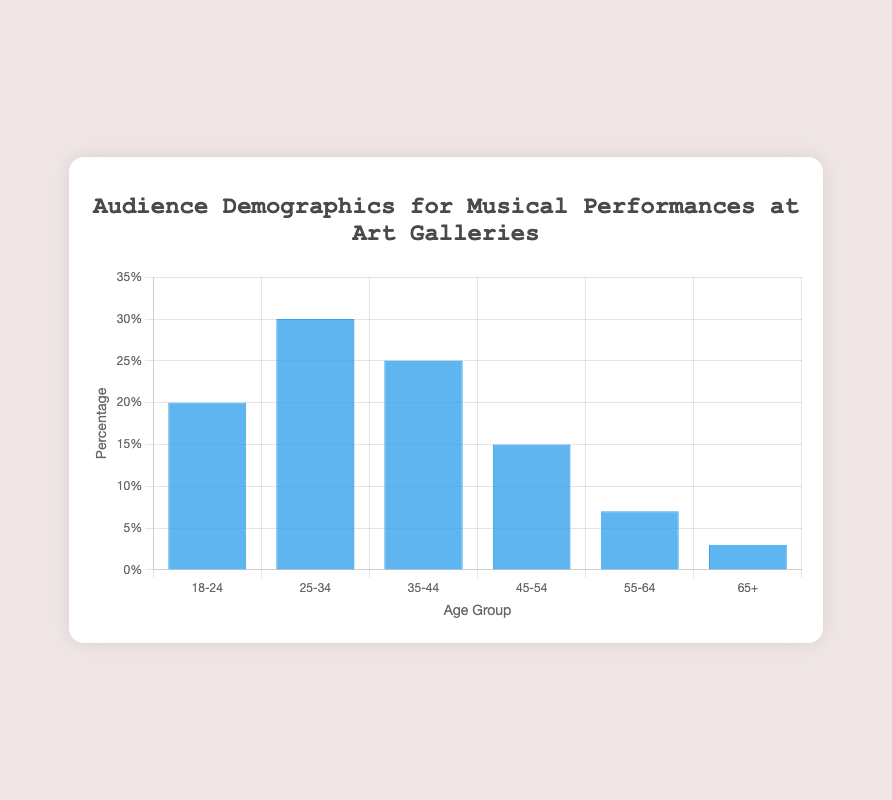Which age group has the highest percentage of the audience? The bar representing the 25-34 age group is the tallest among all the bars. Therefore, the 25-34 age group has the highest percentage.
Answer: 25-34 What is the total percentage of audiences aged 35-54? Sum the percentages of the 35-44 and 45-54 age groups: 25% + 15% = 40%.
Answer: 40% Which age group has a lower percentage of the audience, 55-64 or 65+? Compare the heights of the bars for the 55-64 and 65+ age groups. The 65+ age group has a shorter bar.
Answer: 65+ How much greater is the percentage of the 18-24 age group compared to the 65+ age group? Subtract the percentage of the 65+ age group from the percentage of the 18-24 age group: 20% - 3% = 17%.
Answer: 17% If you combine the percentages of the 18-24 and 25-34 age groups, what is the sum? Add the percentages of the 18-24 and 25-34 age groups: 20% + 30% = 50%.
Answer: 50% Which age group has more than double the percentage of the 55-64 age group? Double the percentage of the 55-64 age group (7% * 2 = 14%). The age groups with percentages greater than 14% are 18-24, 25-34, 35-44, and 45-54. Among these, 18-24, 25-34, and 35-44 age groups have more than double the percentage.
Answer: 18-24, 25-34, 35-44 What is the average percentage of the 35-44 and 45-54 age groups? Calculate the average by adding the percentages of the 35-44 and 45-54 age groups and dividing by 2: (25% + 15%) / 2 = 20%.
Answer: 20% Which age group is closest to 5% in audience percentage? Compare the percentages to find the one closest to 5%. The 55-64 age group has 7%, which is closest to 5%.
Answer: 55-64 What is the difference in percentage between the 25-34 and 35-44 age groups? Subtract the percentage of the 35-44 age group from the percentage of the 25-34 age group: 30% - 25% = 5%.
Answer: 5% Which two age groups' combined percentage equals that of the 25-34 age group? Find two groups whose percentages add up to the percentage of the 25-34 group (30%). The 18-24 and 45-54 groups combined (20% + 15%) sum to 35%, which is the closest combination but slightly exceeds. The 25-34 age group stands alone with its percentage higher and combined percentages of other groups either exceed or fall short. Therefore, there might be no exact equal combination.
Answer: None 